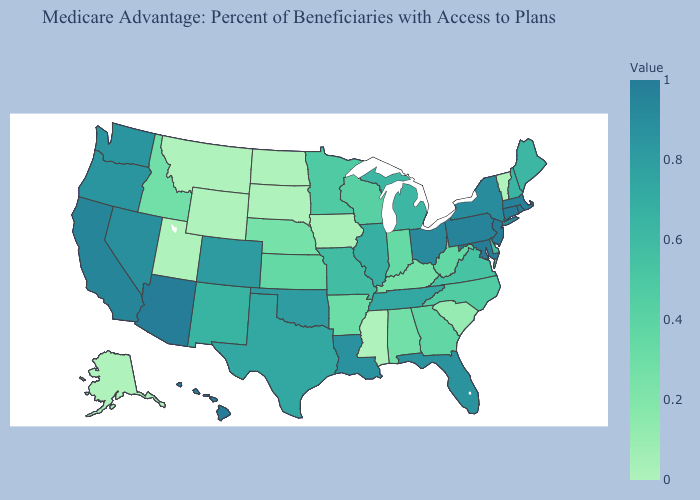Does California have the lowest value in the West?
Be succinct. No. Does Indiana have the lowest value in the USA?
Write a very short answer. No. Among the states that border Virginia , which have the lowest value?
Be succinct. Kentucky. Does the map have missing data?
Concise answer only. No. Does Idaho have the highest value in the USA?
Short answer required. No. 